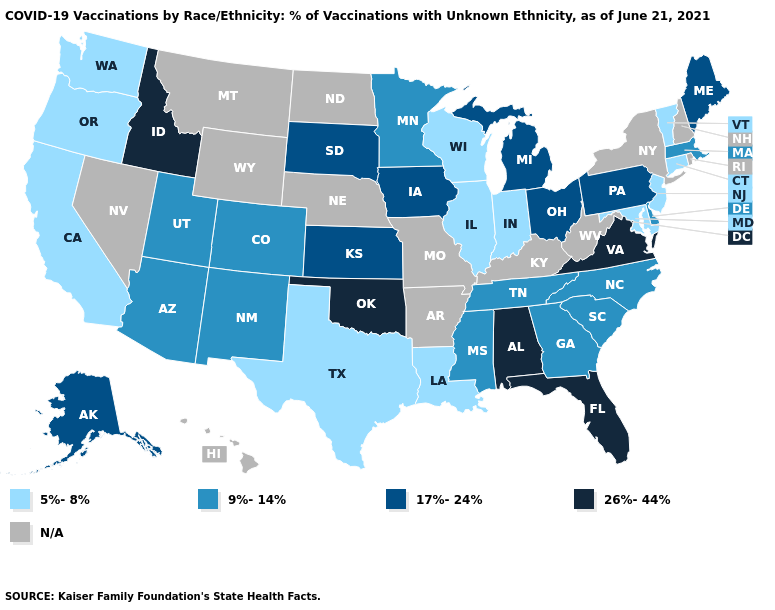What is the value of Connecticut?
Short answer required. 5%-8%. What is the lowest value in the USA?
Keep it brief. 5%-8%. Which states have the highest value in the USA?
Keep it brief. Alabama, Florida, Idaho, Oklahoma, Virginia. Name the states that have a value in the range 5%-8%?
Keep it brief. California, Connecticut, Illinois, Indiana, Louisiana, Maryland, New Jersey, Oregon, Texas, Vermont, Washington, Wisconsin. Name the states that have a value in the range 26%-44%?
Keep it brief. Alabama, Florida, Idaho, Oklahoma, Virginia. Which states hav the highest value in the Northeast?
Give a very brief answer. Maine, Pennsylvania. What is the lowest value in states that border Rhode Island?
Keep it brief. 5%-8%. Name the states that have a value in the range 9%-14%?
Quick response, please. Arizona, Colorado, Delaware, Georgia, Massachusetts, Minnesota, Mississippi, New Mexico, North Carolina, South Carolina, Tennessee, Utah. Name the states that have a value in the range 26%-44%?
Short answer required. Alabama, Florida, Idaho, Oklahoma, Virginia. Name the states that have a value in the range 26%-44%?
Give a very brief answer. Alabama, Florida, Idaho, Oklahoma, Virginia. Does Kansas have the lowest value in the MidWest?
Quick response, please. No. Name the states that have a value in the range 26%-44%?
Be succinct. Alabama, Florida, Idaho, Oklahoma, Virginia. Which states have the highest value in the USA?
Write a very short answer. Alabama, Florida, Idaho, Oklahoma, Virginia. Name the states that have a value in the range 26%-44%?
Write a very short answer. Alabama, Florida, Idaho, Oklahoma, Virginia. Name the states that have a value in the range 26%-44%?
Write a very short answer. Alabama, Florida, Idaho, Oklahoma, Virginia. 